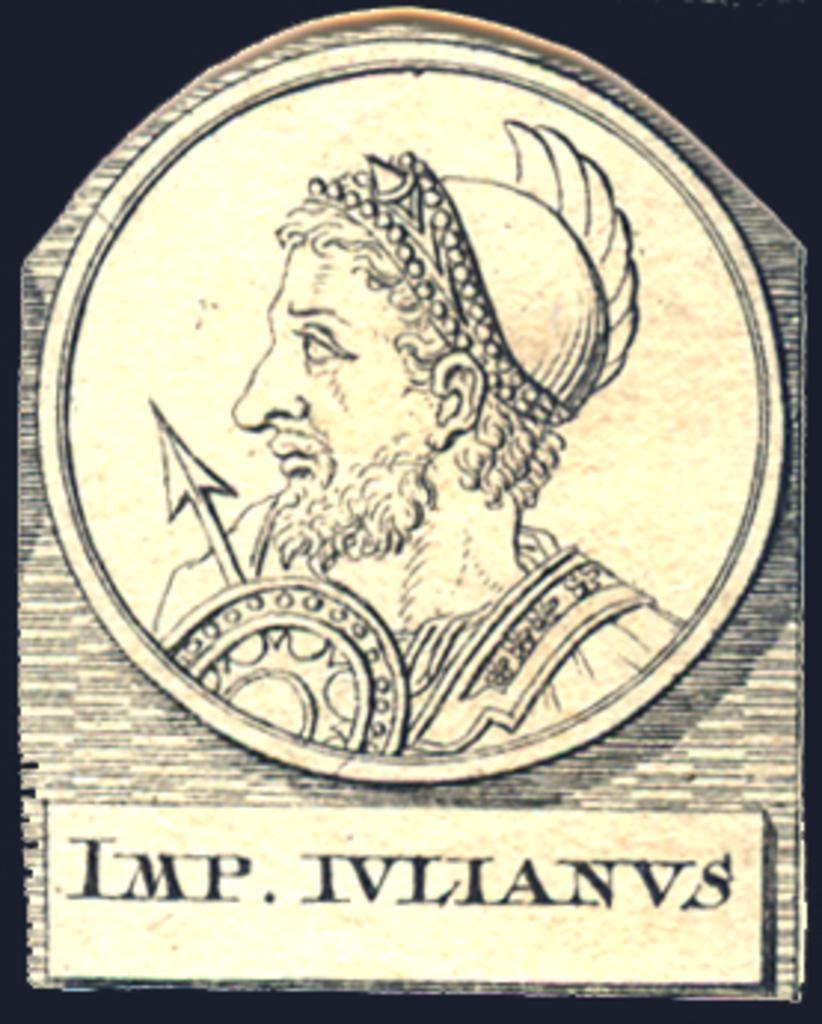Could you give a brief overview of what you see in this image? In the picture we can see a painting of a coin on it we can see a image of a man looking left hand side and to him we can see a arrow and under the painting we can see a name IMP. IVANOVS. 